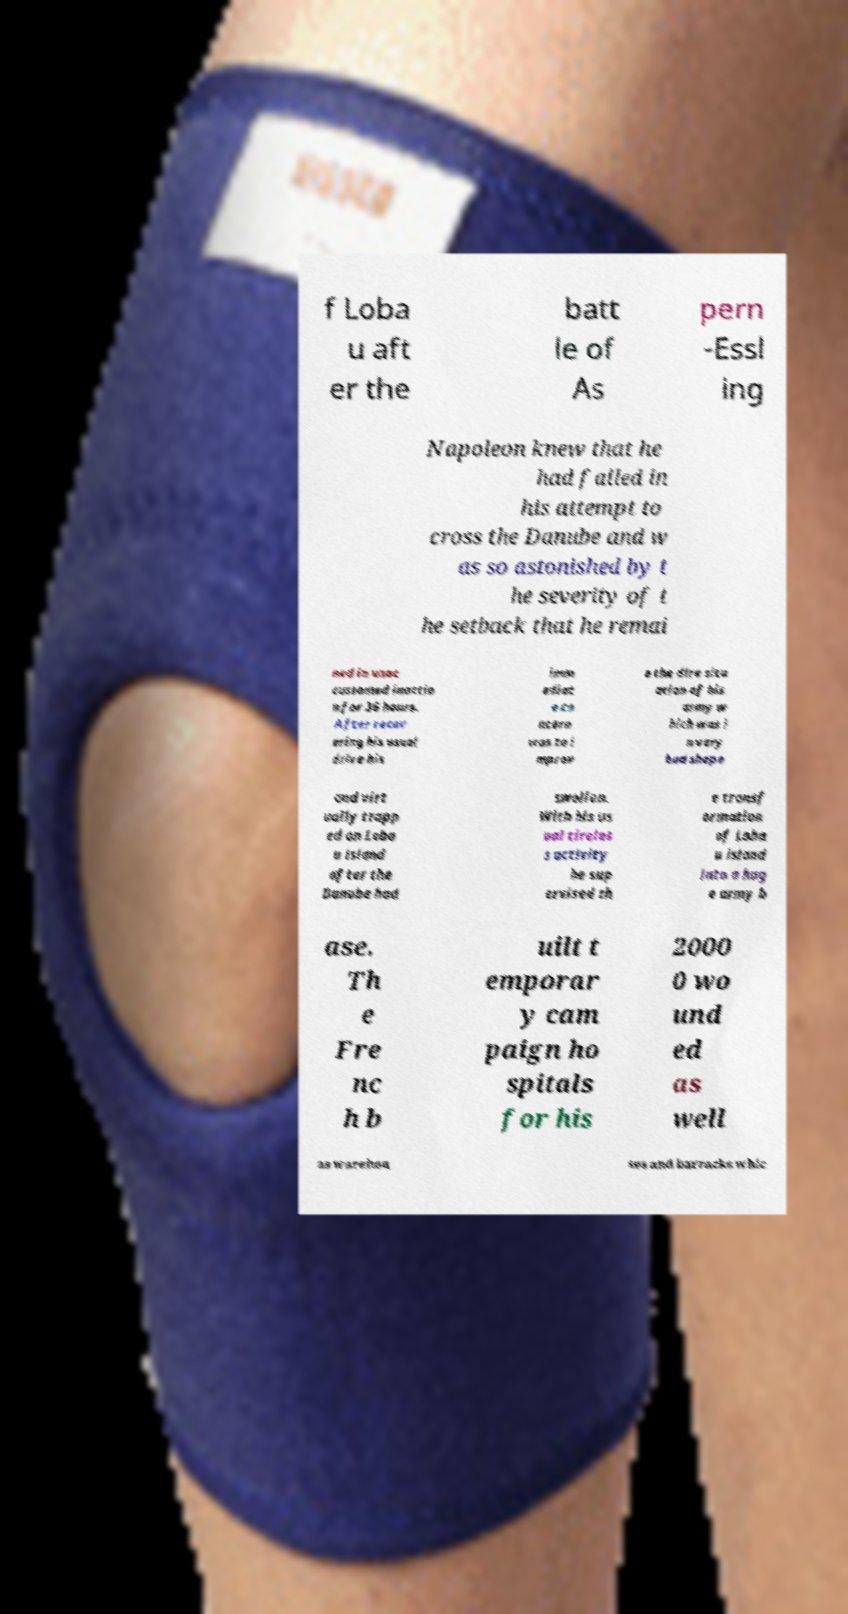Could you extract and type out the text from this image? f Loba u aft er the batt le of As pern -Essl ing Napoleon knew that he had failed in his attempt to cross the Danube and w as so astonished by t he severity of t he setback that he remai ned in unac customed inactio n for 36 hours. After recov ering his usual drive his imm ediat e co ncern was to i mprov e the dire situ ation of his army w hich was i n very bad shape and virt ually trapp ed on Loba u island after the Danube had swollen. With his us ual tireles s activity he sup ervised th e transf ormation of Loba u island into a hug e army b ase. Th e Fre nc h b uilt t emporar y cam paign ho spitals for his 2000 0 wo und ed as well as warehou ses and barracks whic 